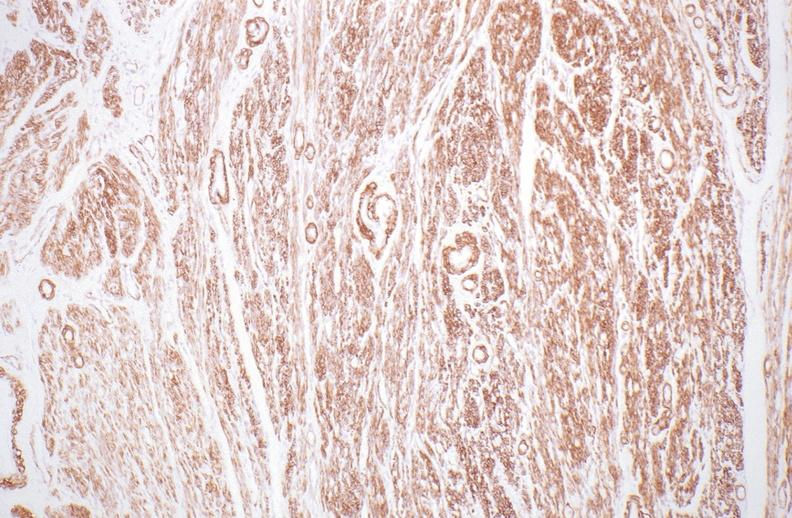where is this from?
Answer the question using a single word or phrase. Female reproductive system 